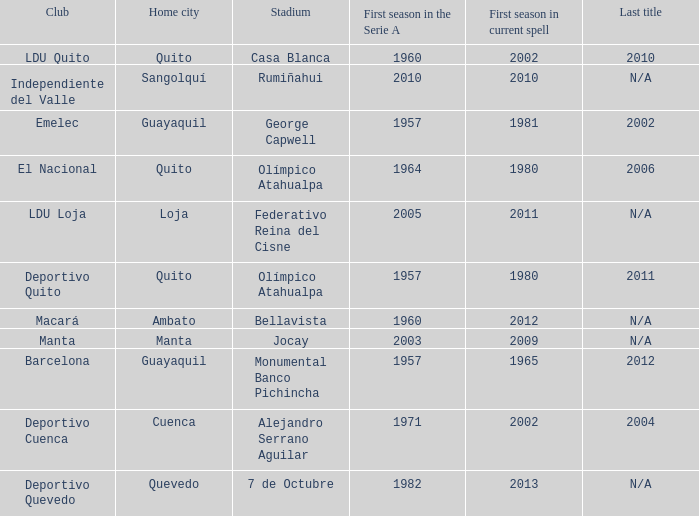Write the full table. {'header': ['Club', 'Home city', 'Stadium', 'First season in the Serie A', 'First season in current spell', 'Last title'], 'rows': [['LDU Quito', 'Quito', 'Casa Blanca', '1960', '2002', '2010'], ['Independiente del Valle', 'Sangolquí', 'Rumiñahui', '2010', '2010', 'N/A'], ['Emelec', 'Guayaquil', 'George Capwell', '1957', '1981', '2002'], ['El Nacional', 'Quito', 'Olímpico Atahualpa', '1964', '1980', '2006'], ['LDU Loja', 'Loja', 'Federativo Reina del Cisne', '2005', '2011', 'N/A'], ['Deportivo Quito', 'Quito', 'Olímpico Atahualpa', '1957', '1980', '2011'], ['Macará', 'Ambato', 'Bellavista', '1960', '2012', 'N/A'], ['Manta', 'Manta', 'Jocay', '2003', '2009', 'N/A'], ['Barcelona', 'Guayaquil', 'Monumental Banco Pichincha', '1957', '1965', '2012'], ['Deportivo Cuenca', 'Cuenca', 'Alejandro Serrano Aguilar', '1971', '2002', '2004'], ['Deportivo Quevedo', 'Quevedo', '7 de Octubre', '1982', '2013', 'N/A']]} Name the last title for 2012 N/A. 